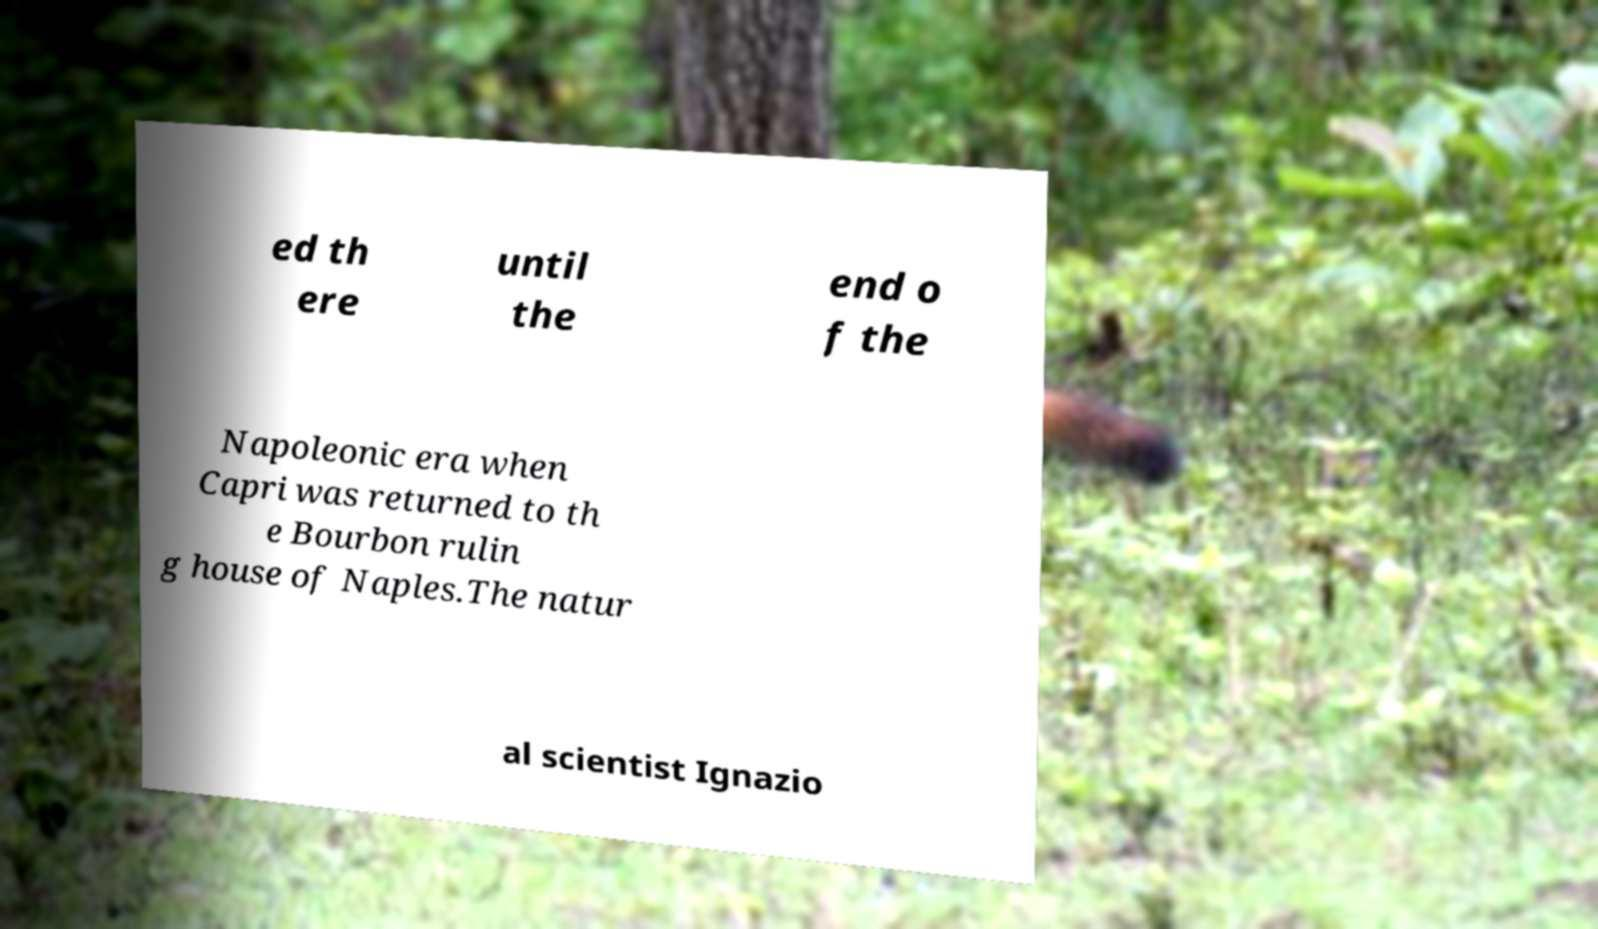Can you accurately transcribe the text from the provided image for me? ed th ere until the end o f the Napoleonic era when Capri was returned to th e Bourbon rulin g house of Naples.The natur al scientist Ignazio 